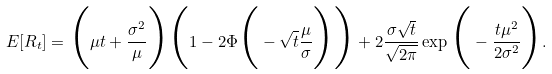<formula> <loc_0><loc_0><loc_500><loc_500>E [ R _ { t } ] = \Big { ( } \mu t + \frac { \sigma ^ { 2 } } { \mu } \Big { ) } \Big { ( } 1 - 2 \Phi \Big { ( } - \sqrt { t } \frac { \mu } { \sigma } \Big { ) } \Big { ) } + 2 \frac { \sigma \sqrt { t } } { \sqrt { 2 \pi } } \exp \Big { ( } - \frac { t \mu ^ { 2 } } { 2 \sigma ^ { 2 } } \Big { ) } .</formula> 